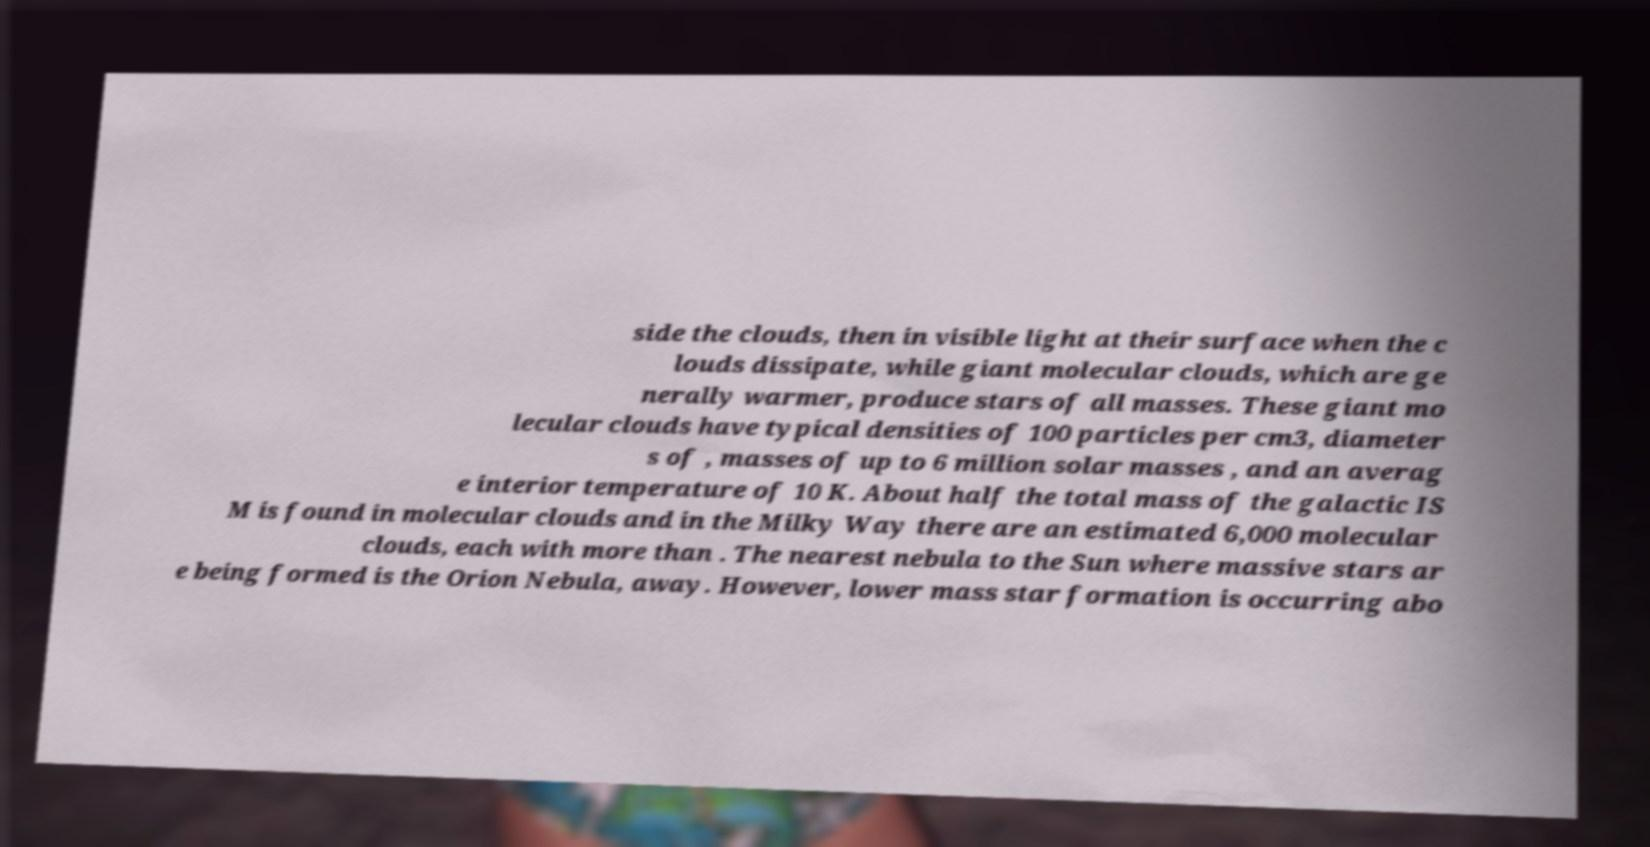Please read and relay the text visible in this image. What does it say? side the clouds, then in visible light at their surface when the c louds dissipate, while giant molecular clouds, which are ge nerally warmer, produce stars of all masses. These giant mo lecular clouds have typical densities of 100 particles per cm3, diameter s of , masses of up to 6 million solar masses , and an averag e interior temperature of 10 K. About half the total mass of the galactic IS M is found in molecular clouds and in the Milky Way there are an estimated 6,000 molecular clouds, each with more than . The nearest nebula to the Sun where massive stars ar e being formed is the Orion Nebula, away. However, lower mass star formation is occurring abo 